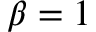Convert formula to latex. <formula><loc_0><loc_0><loc_500><loc_500>\beta = 1</formula> 